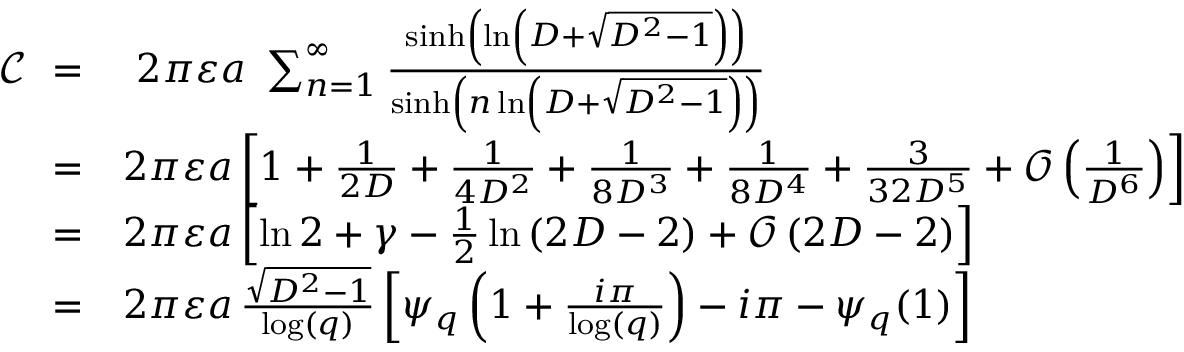Convert formula to latex. <formula><loc_0><loc_0><loc_500><loc_500>{ \begin{array} { r l } { \ { \mathcal { C } } \ = } & { \ 2 \pi \varepsilon a \ \sum _ { n = 1 } ^ { \infty } { \frac { \sinh \left ( \ln \left ( D + { \sqrt { D ^ { 2 } - 1 } } \right ) \right ) } { \sinh \left ( n \ln \left ( D + { \sqrt { D ^ { 2 } - 1 } } \right ) \right ) } } } \\ { = } & { 2 \pi \varepsilon a \left [ 1 + { \frac { 1 } { 2 D } } + { \frac { 1 } { 4 D ^ { 2 } } } + { \frac { 1 } { 8 D ^ { 3 } } } + { \frac { 1 } { 8 D ^ { 4 } } } + { \frac { 3 } { 3 2 D ^ { 5 } } } + { \mathcal { O } } \left ( { \frac { 1 } { D ^ { 6 } } } \right ) \right ] } \\ { = } & { 2 \pi \varepsilon a \left [ \ln 2 + \gamma - { \frac { 1 } { 2 } } \ln \left ( 2 D - 2 \right ) + { \mathcal { O } } \left ( 2 D - 2 \right ) \right ] } \\ { = } & { 2 \pi \varepsilon a \, { \frac { \sqrt { D ^ { 2 } - 1 } } { \log ( q ) } } \left [ \psi _ { q } \left ( 1 + { \frac { i \pi } { \log ( q ) } } \right ) - i \pi - \psi _ { q } ( 1 ) \right ] } \end{array} }</formula> 